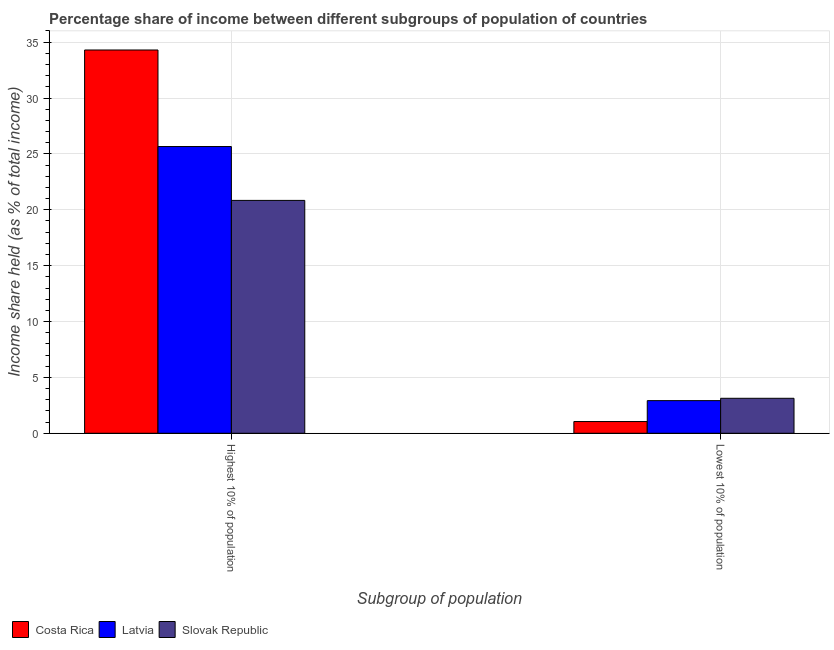Are the number of bars on each tick of the X-axis equal?
Offer a terse response. Yes. How many bars are there on the 2nd tick from the right?
Your answer should be compact. 3. What is the label of the 2nd group of bars from the left?
Keep it short and to the point. Lowest 10% of population. What is the income share held by highest 10% of the population in Slovak Republic?
Offer a terse response. 20.84. Across all countries, what is the maximum income share held by highest 10% of the population?
Your answer should be very brief. 34.3. In which country was the income share held by lowest 10% of the population maximum?
Keep it short and to the point. Slovak Republic. What is the total income share held by highest 10% of the population in the graph?
Give a very brief answer. 80.8. What is the difference between the income share held by highest 10% of the population in Slovak Republic and that in Costa Rica?
Offer a very short reply. -13.46. What is the difference between the income share held by lowest 10% of the population in Latvia and the income share held by highest 10% of the population in Costa Rica?
Your response must be concise. -31.38. What is the average income share held by lowest 10% of the population per country?
Your answer should be compact. 2.37. What is the difference between the income share held by lowest 10% of the population and income share held by highest 10% of the population in Costa Rica?
Make the answer very short. -33.25. In how many countries, is the income share held by lowest 10% of the population greater than 28 %?
Give a very brief answer. 0. What is the ratio of the income share held by highest 10% of the population in Slovak Republic to that in Latvia?
Your answer should be compact. 0.81. Is the income share held by highest 10% of the population in Costa Rica less than that in Latvia?
Keep it short and to the point. No. What does the 2nd bar from the left in Highest 10% of population represents?
Your answer should be very brief. Latvia. What does the 2nd bar from the right in Highest 10% of population represents?
Your answer should be compact. Latvia. How many bars are there?
Keep it short and to the point. 6. Are all the bars in the graph horizontal?
Ensure brevity in your answer.  No. How many countries are there in the graph?
Make the answer very short. 3. Does the graph contain grids?
Your response must be concise. Yes. How are the legend labels stacked?
Make the answer very short. Horizontal. What is the title of the graph?
Provide a succinct answer. Percentage share of income between different subgroups of population of countries. What is the label or title of the X-axis?
Keep it short and to the point. Subgroup of population. What is the label or title of the Y-axis?
Your answer should be very brief. Income share held (as % of total income). What is the Income share held (as % of total income) of Costa Rica in Highest 10% of population?
Keep it short and to the point. 34.3. What is the Income share held (as % of total income) of Latvia in Highest 10% of population?
Ensure brevity in your answer.  25.66. What is the Income share held (as % of total income) in Slovak Republic in Highest 10% of population?
Ensure brevity in your answer.  20.84. What is the Income share held (as % of total income) of Latvia in Lowest 10% of population?
Your answer should be compact. 2.92. What is the Income share held (as % of total income) in Slovak Republic in Lowest 10% of population?
Keep it short and to the point. 3.13. Across all Subgroup of population, what is the maximum Income share held (as % of total income) in Costa Rica?
Keep it short and to the point. 34.3. Across all Subgroup of population, what is the maximum Income share held (as % of total income) of Latvia?
Make the answer very short. 25.66. Across all Subgroup of population, what is the maximum Income share held (as % of total income) of Slovak Republic?
Offer a very short reply. 20.84. Across all Subgroup of population, what is the minimum Income share held (as % of total income) of Latvia?
Provide a succinct answer. 2.92. Across all Subgroup of population, what is the minimum Income share held (as % of total income) of Slovak Republic?
Offer a very short reply. 3.13. What is the total Income share held (as % of total income) in Costa Rica in the graph?
Make the answer very short. 35.35. What is the total Income share held (as % of total income) in Latvia in the graph?
Keep it short and to the point. 28.58. What is the total Income share held (as % of total income) in Slovak Republic in the graph?
Provide a short and direct response. 23.97. What is the difference between the Income share held (as % of total income) in Costa Rica in Highest 10% of population and that in Lowest 10% of population?
Provide a short and direct response. 33.25. What is the difference between the Income share held (as % of total income) of Latvia in Highest 10% of population and that in Lowest 10% of population?
Your answer should be compact. 22.74. What is the difference between the Income share held (as % of total income) in Slovak Republic in Highest 10% of population and that in Lowest 10% of population?
Make the answer very short. 17.71. What is the difference between the Income share held (as % of total income) in Costa Rica in Highest 10% of population and the Income share held (as % of total income) in Latvia in Lowest 10% of population?
Ensure brevity in your answer.  31.38. What is the difference between the Income share held (as % of total income) in Costa Rica in Highest 10% of population and the Income share held (as % of total income) in Slovak Republic in Lowest 10% of population?
Keep it short and to the point. 31.17. What is the difference between the Income share held (as % of total income) of Latvia in Highest 10% of population and the Income share held (as % of total income) of Slovak Republic in Lowest 10% of population?
Ensure brevity in your answer.  22.53. What is the average Income share held (as % of total income) of Costa Rica per Subgroup of population?
Offer a very short reply. 17.68. What is the average Income share held (as % of total income) of Latvia per Subgroup of population?
Ensure brevity in your answer.  14.29. What is the average Income share held (as % of total income) in Slovak Republic per Subgroup of population?
Provide a succinct answer. 11.98. What is the difference between the Income share held (as % of total income) in Costa Rica and Income share held (as % of total income) in Latvia in Highest 10% of population?
Offer a very short reply. 8.64. What is the difference between the Income share held (as % of total income) of Costa Rica and Income share held (as % of total income) of Slovak Republic in Highest 10% of population?
Offer a terse response. 13.46. What is the difference between the Income share held (as % of total income) in Latvia and Income share held (as % of total income) in Slovak Republic in Highest 10% of population?
Your answer should be very brief. 4.82. What is the difference between the Income share held (as % of total income) of Costa Rica and Income share held (as % of total income) of Latvia in Lowest 10% of population?
Ensure brevity in your answer.  -1.87. What is the difference between the Income share held (as % of total income) of Costa Rica and Income share held (as % of total income) of Slovak Republic in Lowest 10% of population?
Make the answer very short. -2.08. What is the difference between the Income share held (as % of total income) of Latvia and Income share held (as % of total income) of Slovak Republic in Lowest 10% of population?
Your response must be concise. -0.21. What is the ratio of the Income share held (as % of total income) of Costa Rica in Highest 10% of population to that in Lowest 10% of population?
Ensure brevity in your answer.  32.67. What is the ratio of the Income share held (as % of total income) of Latvia in Highest 10% of population to that in Lowest 10% of population?
Offer a terse response. 8.79. What is the ratio of the Income share held (as % of total income) in Slovak Republic in Highest 10% of population to that in Lowest 10% of population?
Your answer should be compact. 6.66. What is the difference between the highest and the second highest Income share held (as % of total income) of Costa Rica?
Offer a very short reply. 33.25. What is the difference between the highest and the second highest Income share held (as % of total income) of Latvia?
Provide a short and direct response. 22.74. What is the difference between the highest and the second highest Income share held (as % of total income) of Slovak Republic?
Ensure brevity in your answer.  17.71. What is the difference between the highest and the lowest Income share held (as % of total income) in Costa Rica?
Offer a terse response. 33.25. What is the difference between the highest and the lowest Income share held (as % of total income) in Latvia?
Your response must be concise. 22.74. What is the difference between the highest and the lowest Income share held (as % of total income) of Slovak Republic?
Provide a short and direct response. 17.71. 